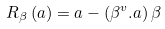<formula> <loc_0><loc_0><loc_500><loc_500>R _ { \beta } \left ( a \right ) = a - \left ( \beta ^ { v } . a \right ) \beta</formula> 